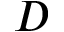Convert formula to latex. <formula><loc_0><loc_0><loc_500><loc_500>D</formula> 